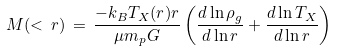<formula> <loc_0><loc_0><loc_500><loc_500>M ( < \, r ) \, = \, \frac { - k _ { B } T _ { X } ( r ) r } { \mu m _ { p } G } \left ( \frac { d \ln \rho _ { g } } { d \ln r } + \frac { d \ln T _ { X } } { d \ln r } \right )</formula> 